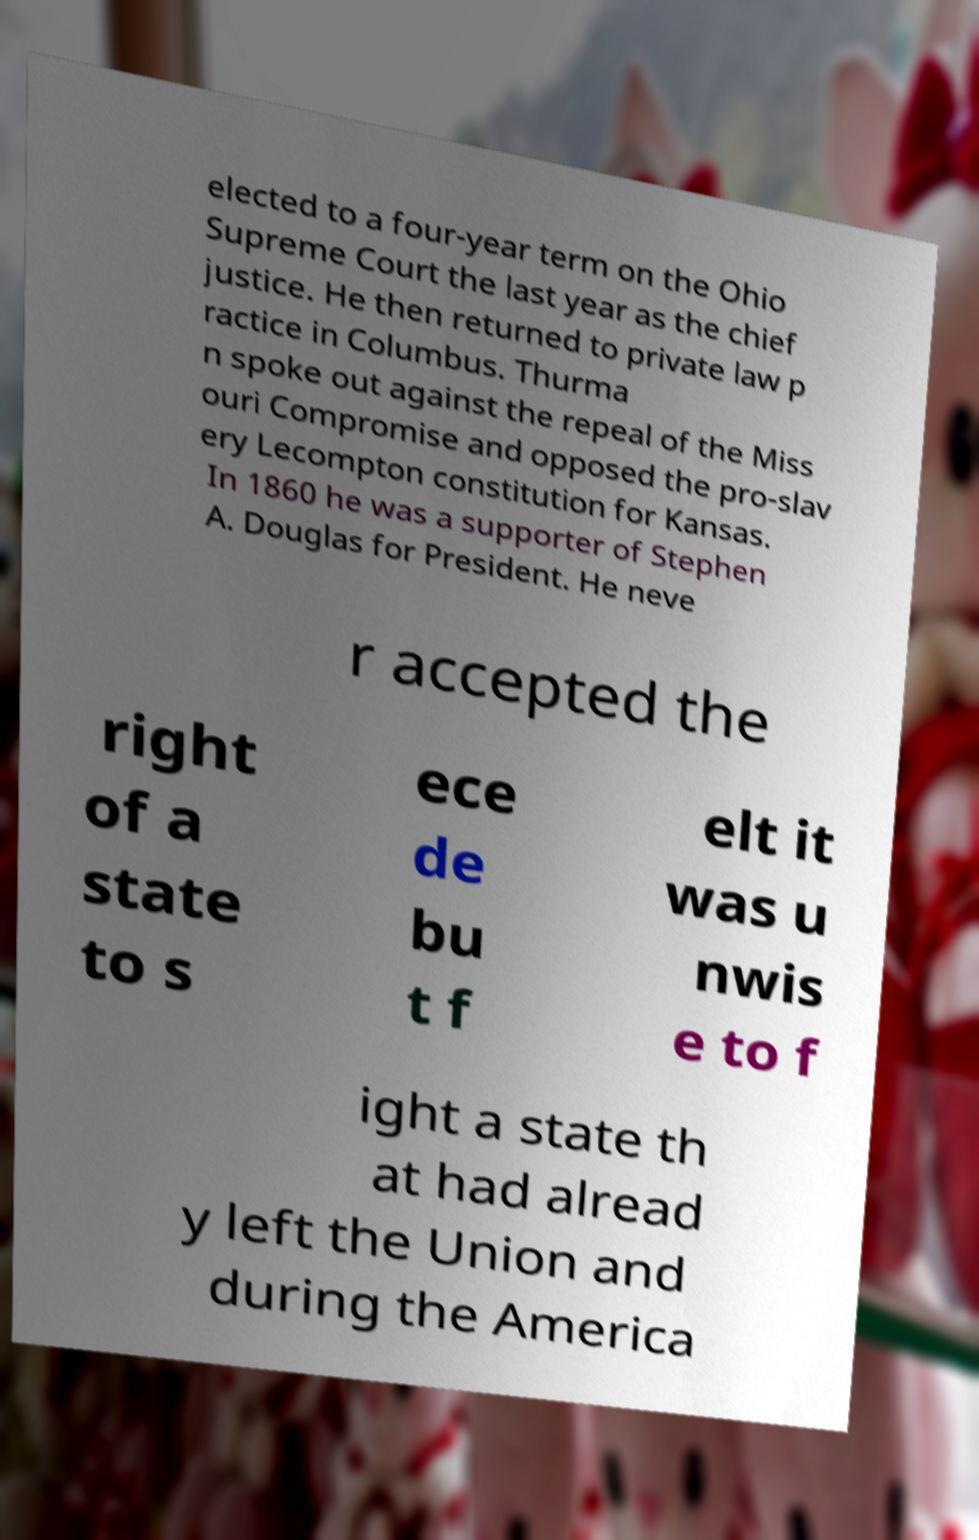For documentation purposes, I need the text within this image transcribed. Could you provide that? elected to a four-year term on the Ohio Supreme Court the last year as the chief justice. He then returned to private law p ractice in Columbus. Thurma n spoke out against the repeal of the Miss ouri Compromise and opposed the pro-slav ery Lecompton constitution for Kansas. In 1860 he was a supporter of Stephen A. Douglas for President. He neve r accepted the right of a state to s ece de bu t f elt it was u nwis e to f ight a state th at had alread y left the Union and during the America 